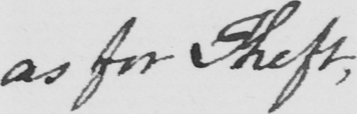Can you read and transcribe this handwriting? as for Theft , 